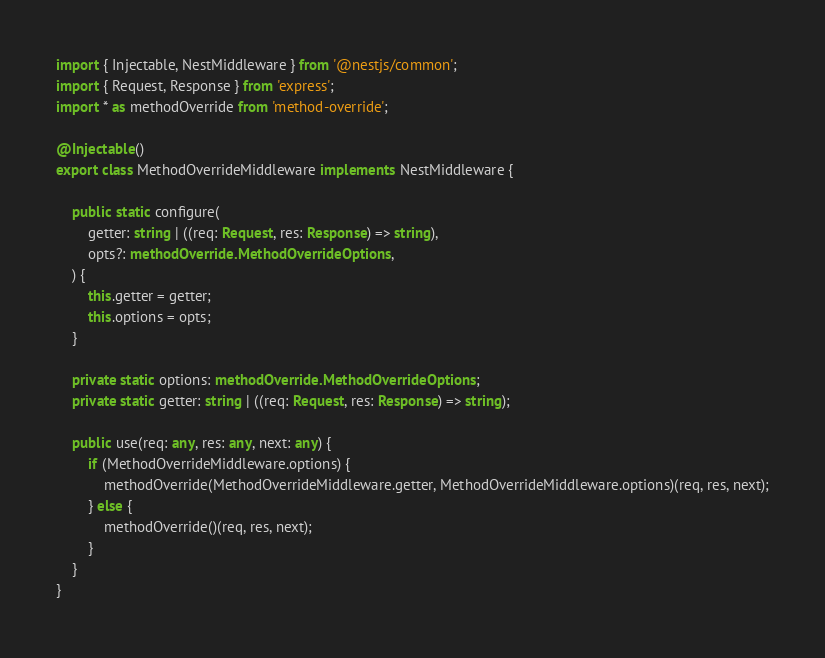Convert code to text. <code><loc_0><loc_0><loc_500><loc_500><_TypeScript_>import { Injectable, NestMiddleware } from '@nestjs/common';
import { Request, Response } from 'express';
import * as methodOverride from 'method-override';

@Injectable()
export class MethodOverrideMiddleware implements NestMiddleware {

    public static configure(
        getter: string | ((req: Request, res: Response) => string),
        opts?: methodOverride.MethodOverrideOptions,
    ) {
        this.getter = getter;
        this.options = opts;
    }

    private static options: methodOverride.MethodOverrideOptions;
    private static getter: string | ((req: Request, res: Response) => string);

    public use(req: any, res: any, next: any) {
        if (MethodOverrideMiddleware.options) {
            methodOverride(MethodOverrideMiddleware.getter, MethodOverrideMiddleware.options)(req, res, next);
        } else {
            methodOverride()(req, res, next);
        }
    }
}
</code> 